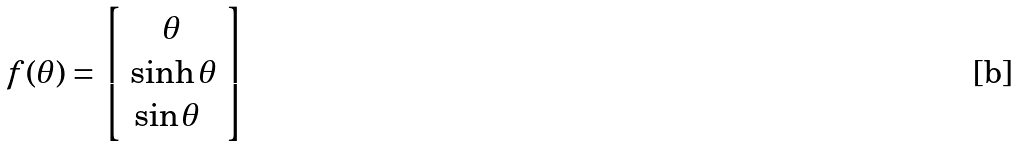Convert formula to latex. <formula><loc_0><loc_0><loc_500><loc_500>f ( \theta ) = \left [ \begin{array} { l l l } \quad \theta \\ \sinh \theta \\ \, \sin \theta \end{array} \right ]</formula> 